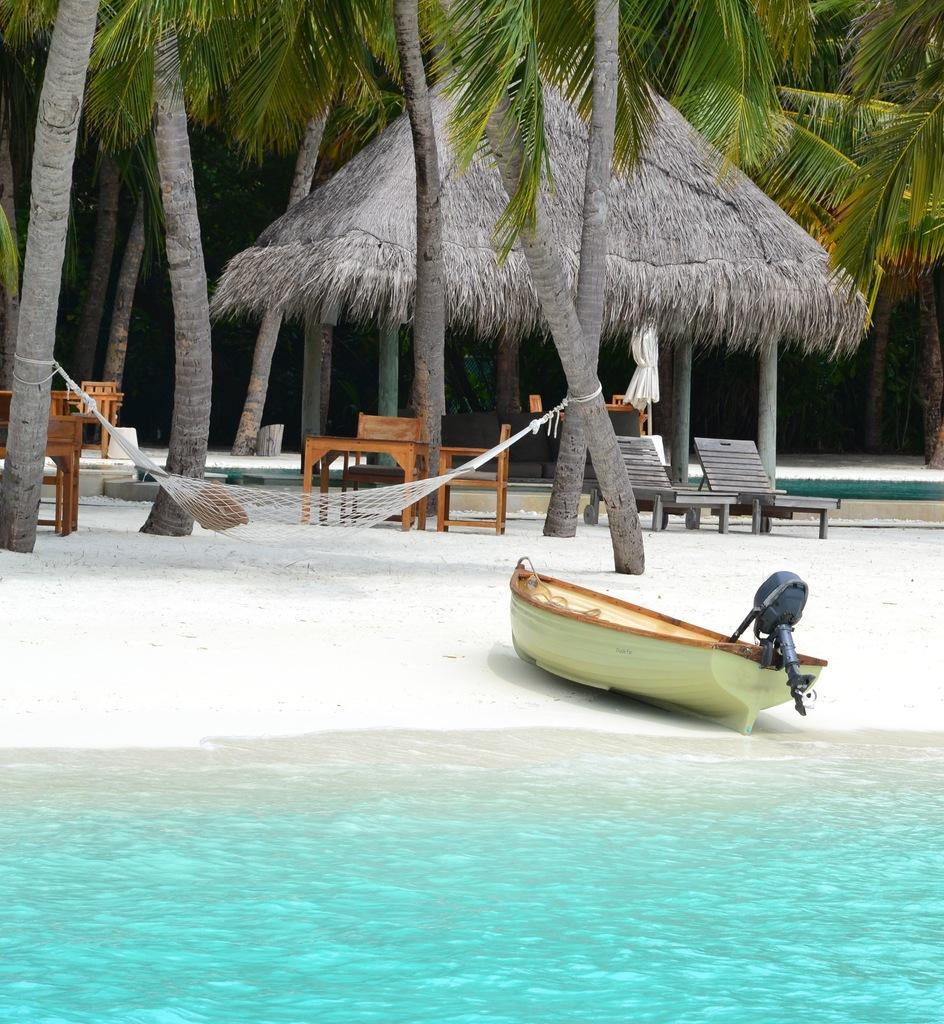How would you summarize this image in a sentence or two? In this image we can see a boat, water, jet, tables and chairs, hut and trees 